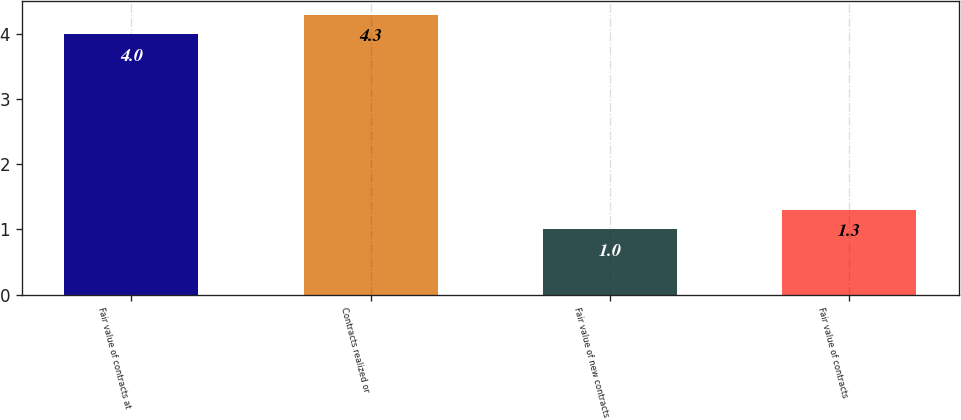Convert chart to OTSL. <chart><loc_0><loc_0><loc_500><loc_500><bar_chart><fcel>Fair value of contracts at<fcel>Contracts realized or<fcel>Fair value of new contracts<fcel>Fair value of contracts<nl><fcel>4<fcel>4.3<fcel>1<fcel>1.3<nl></chart> 